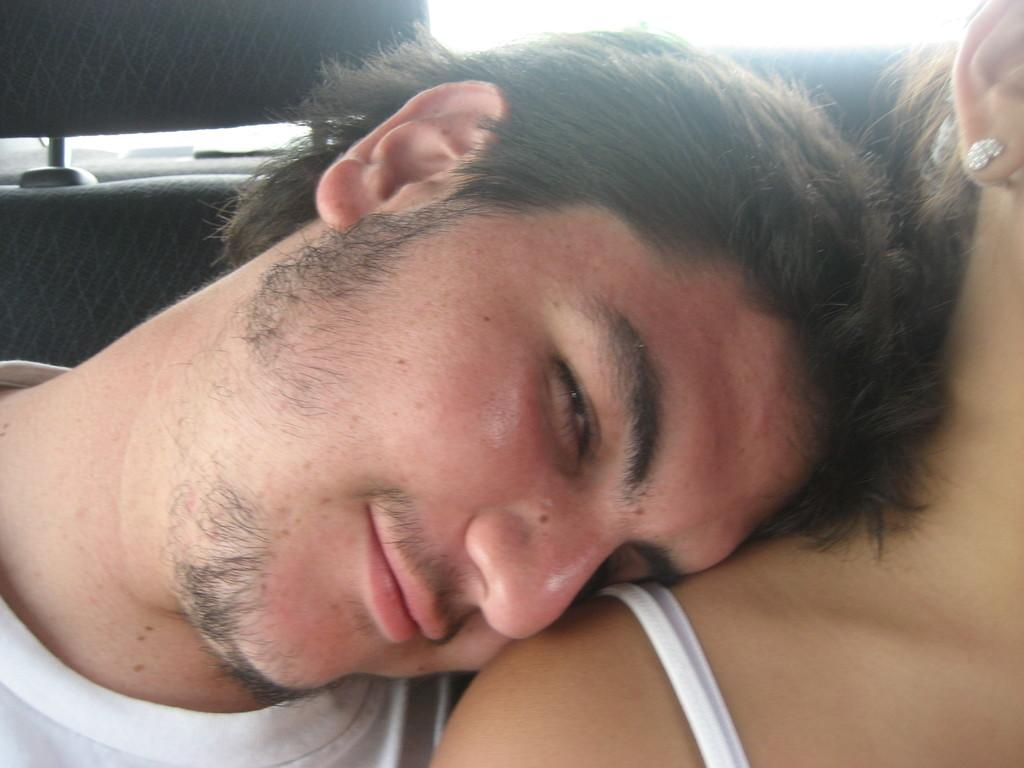What is the person in the image wearing? The person in the image is wearing a white T-shirt. How is the person in the image positioned? The person is lying on the shoulder of another person. What can be seen in the background of the image? There is light visible in the background of the image. What type of territory is being claimed by the person in the image? There is no indication in the image that the person is claiming any territory. Can you see any railway tracks in the image? There are no railway tracks visible in the image. 